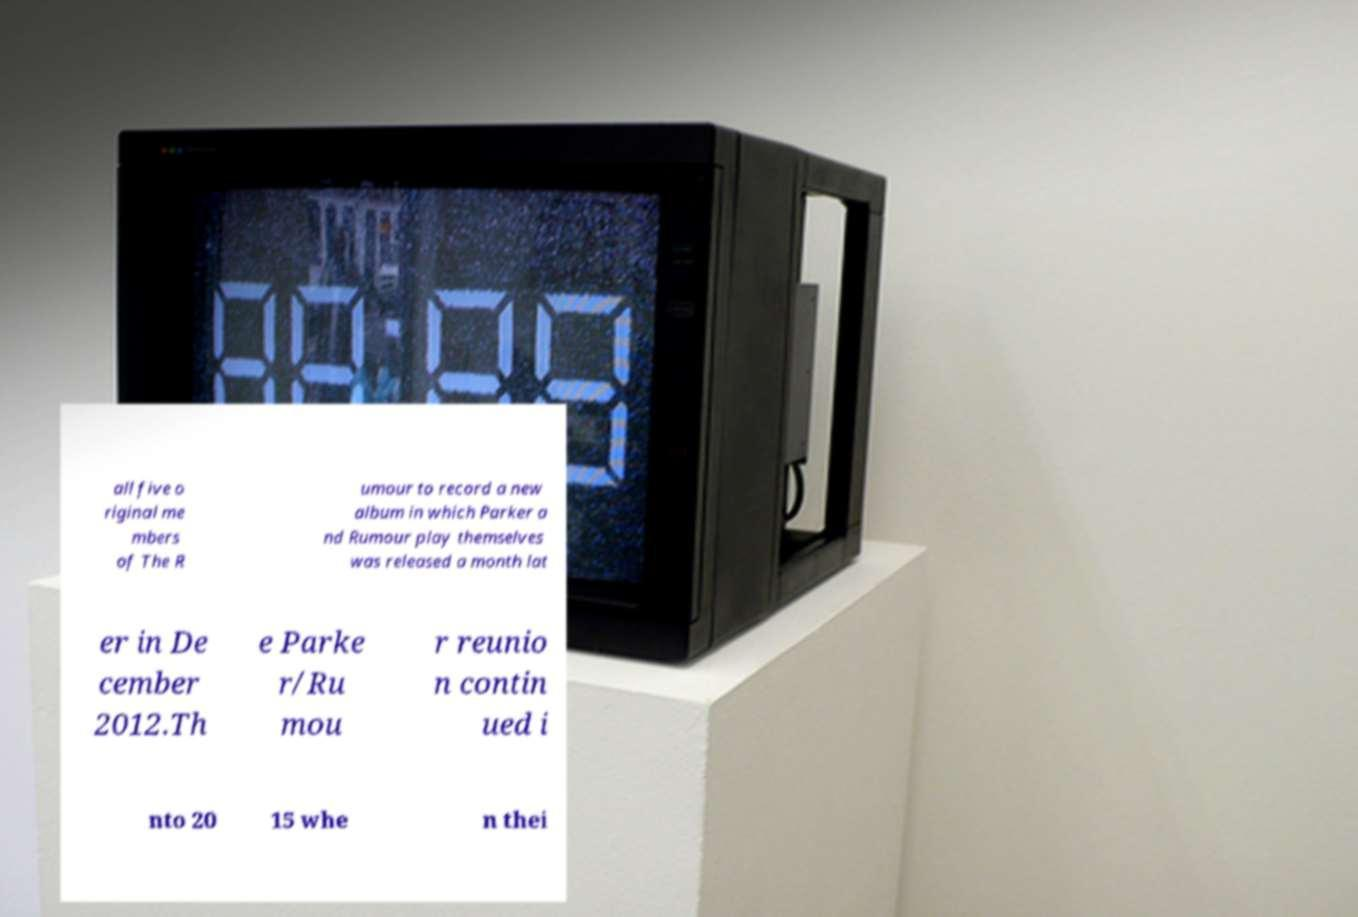What messages or text are displayed in this image? I need them in a readable, typed format. all five o riginal me mbers of The R umour to record a new album in which Parker a nd Rumour play themselves was released a month lat er in De cember 2012.Th e Parke r/Ru mou r reunio n contin ued i nto 20 15 whe n thei 